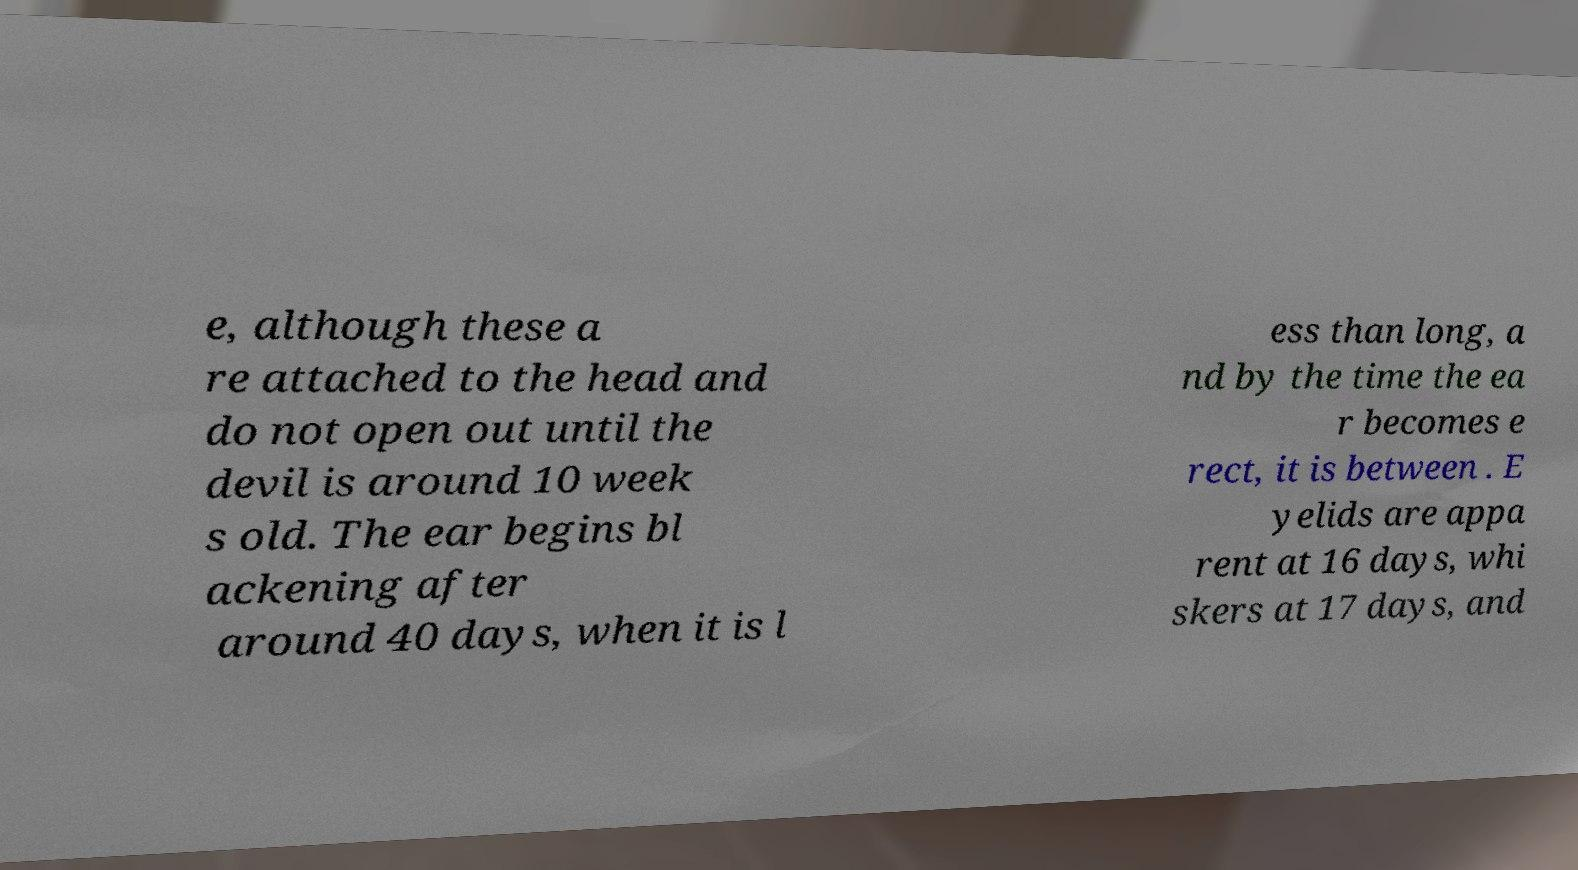Could you assist in decoding the text presented in this image and type it out clearly? e, although these a re attached to the head and do not open out until the devil is around 10 week s old. The ear begins bl ackening after around 40 days, when it is l ess than long, a nd by the time the ea r becomes e rect, it is between . E yelids are appa rent at 16 days, whi skers at 17 days, and 